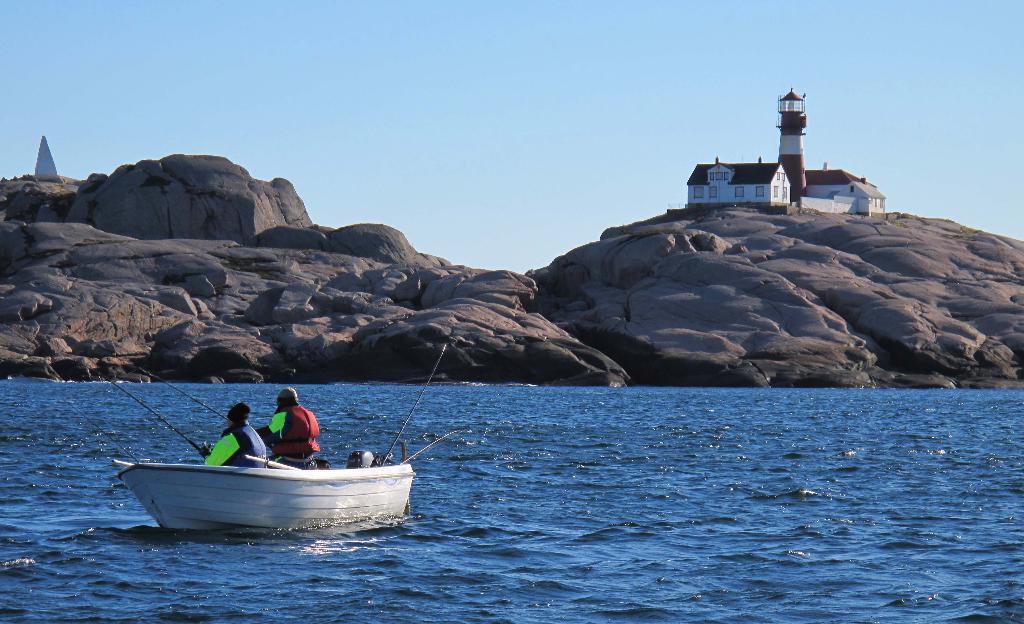In one or two sentences, can you explain what this image depicts? In this image in the center there is a boat sailing on the water with the persons sitting inside it. In the background there are rocks and there are houses and there is a tower. 